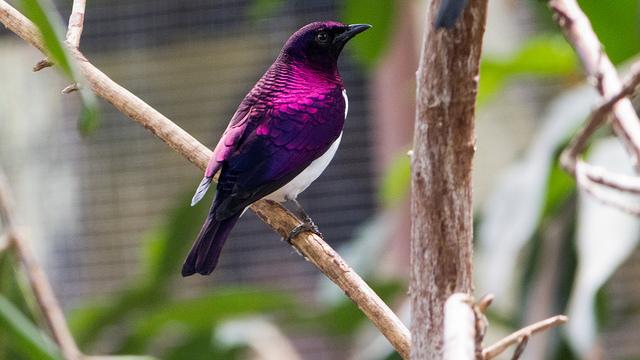What color is the bird's chest?
Give a very brief answer. White. What color is the bird?
Quick response, please. Purple. Is this bird caged?
Quick response, please. No. 